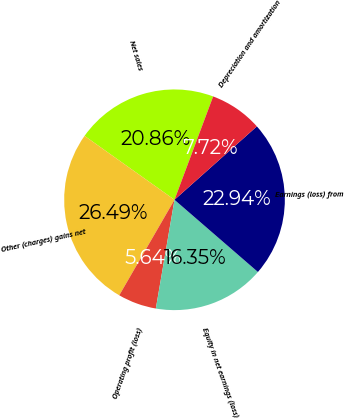<chart> <loc_0><loc_0><loc_500><loc_500><pie_chart><fcel>Net sales<fcel>Other (charges) gains net<fcel>Operating profit (loss)<fcel>Equity in net earnings (loss)<fcel>Earnings (loss) from<fcel>Depreciation and amortization<nl><fcel>20.86%<fcel>26.49%<fcel>5.64%<fcel>16.35%<fcel>22.94%<fcel>7.72%<nl></chart> 